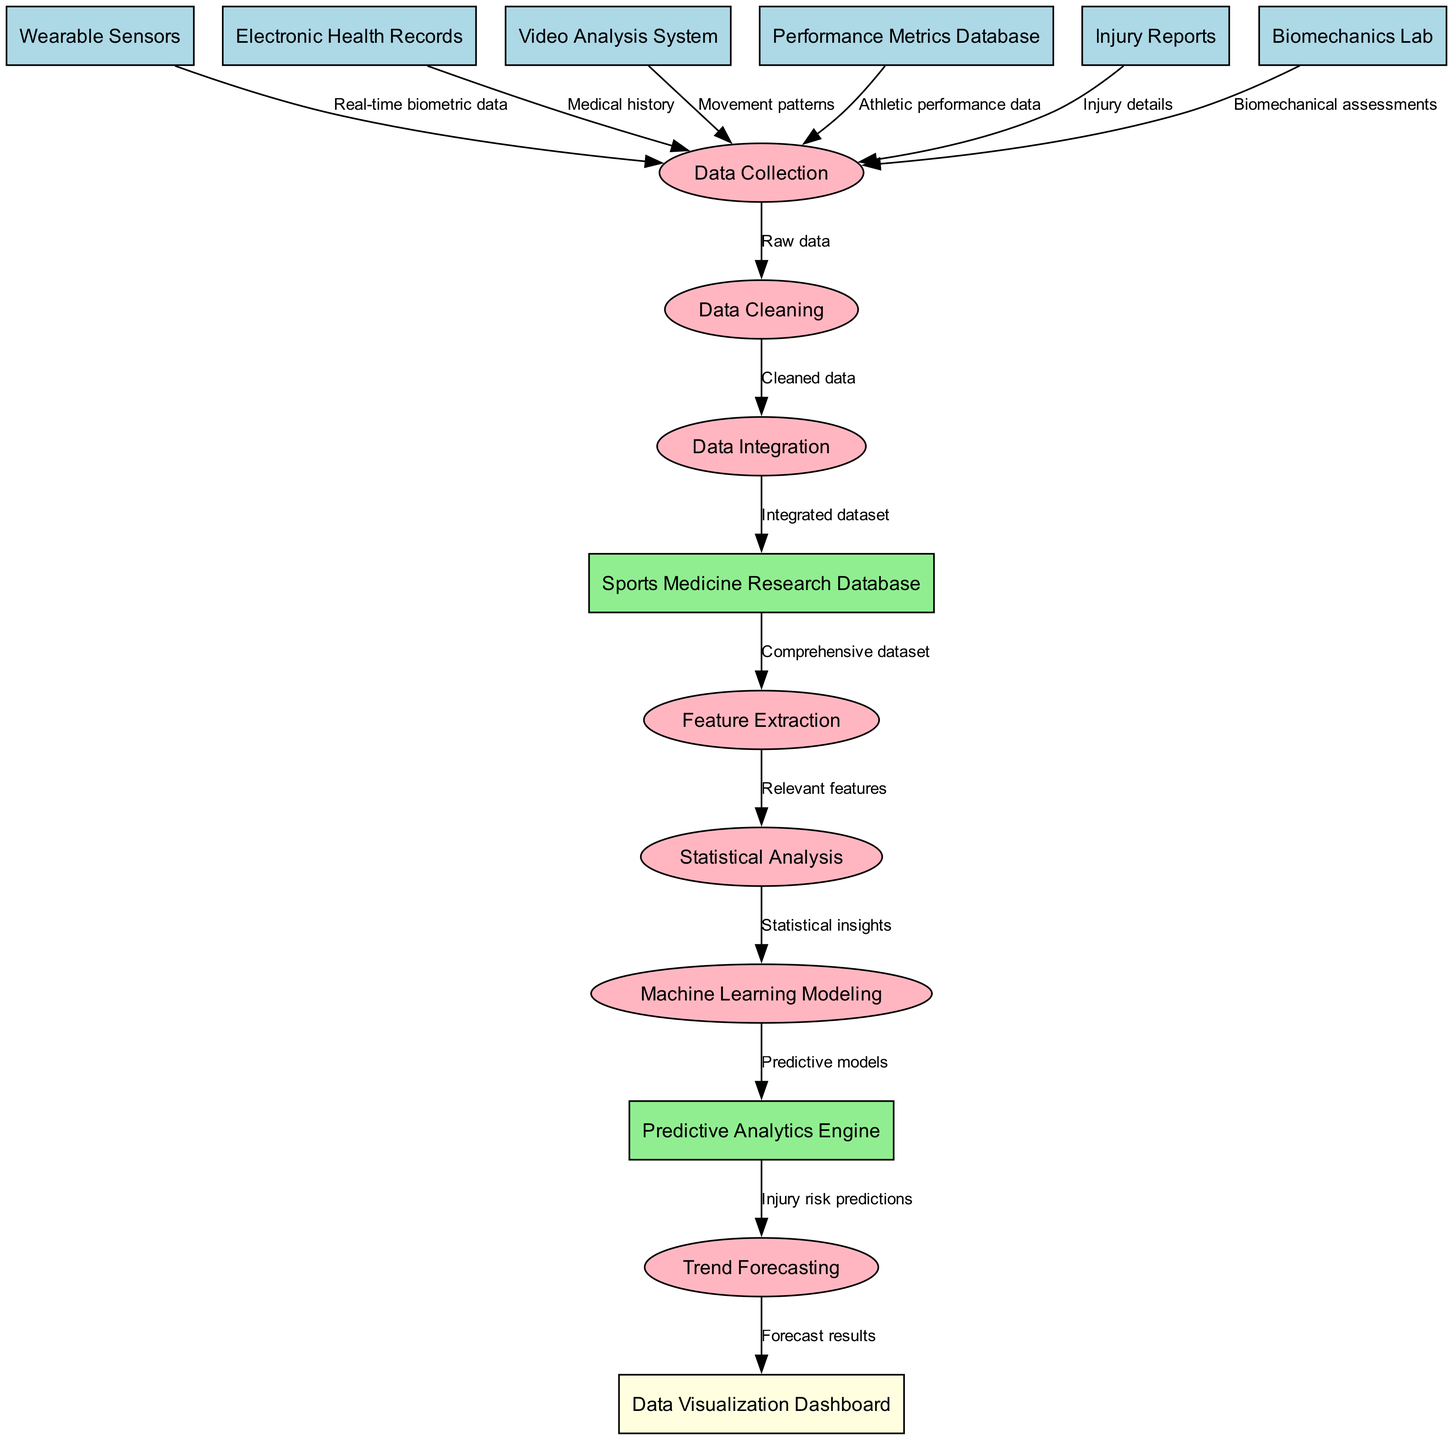What are the two main types of data sources in the diagram? The diagram shows data sources categorized as entities, with two main types being 'Wearable Sensors' and 'Electronic Health Records'.
Answer: Wearable Sensors, Electronic Health Records How many processes are there in the diagram? By counting the listed processes in the diagram, we find there are a total of seven distinct processes.
Answer: Seven Which entity sends injury details to data collection? The data flow indicates that 'Injury Reports' is the entity responsible for sending injury details to the data collection process.
Answer: Injury Reports What is the output from the statistical analysis process? The output from the 'Statistical Analysis' process feeds directly into 'Machine Learning Modeling', providing statistical insights as the output.
Answer: Statistical insights What data does 'Data Integration' receive? 'Data Integration' receives 'Cleaned data' as input from the previous process, 'Data Cleaning', indicating it incorporates data that has been prepped for analysis.
Answer: Cleaned data Which entity provides biomechanical assessments to the data collection process? According to the data flow, 'Biomechanics Lab' is the entity that provides biomechanical assessments to the data collection process.
Answer: Biomechanics Lab What is the final output of the trend forecasting process? The final output from the 'Trend Forecasting' process is displayed as 'Forecast results', which is sent to the 'Data Visualization Dashboard'.
Answer: Forecast results What transformation occurs between data collection and data cleaning? The transformation involves taking 'Raw data' from 'Data Collection' and processing it to produce 'Cleaned data' for the next step.
Answer: Cleaned data How does 'Machine Learning Modeling' contribute to predictive analytics? 'Machine Learning Modeling' outputs 'Predictive models', which are sent to the 'Predictive Analytics Engine' for further processing and analysis.
Answer: Predictive models Which two processes are directly linked by a data flow? The processes 'Data Cleaning' and 'Data Integration' are directly linked, as they flow sequentially in the diagram.
Answer: Data Cleaning, Data Integration 